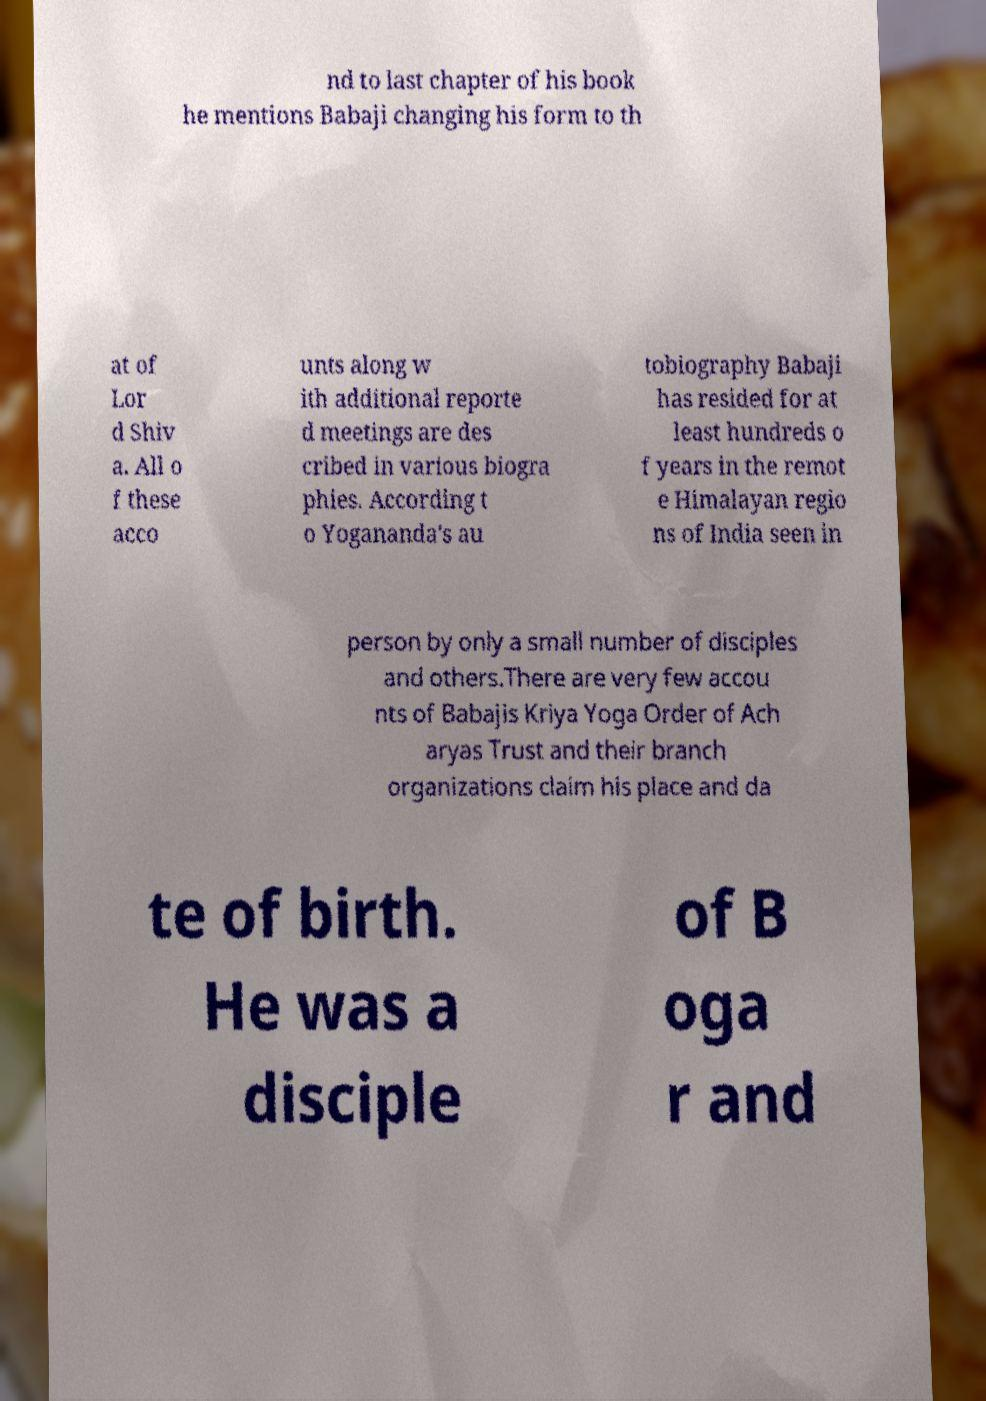I need the written content from this picture converted into text. Can you do that? nd to last chapter of his book he mentions Babaji changing his form to th at of Lor d Shiv a. All o f these acco unts along w ith additional reporte d meetings are des cribed in various biogra phies. According t o Yogananda's au tobiography Babaji has resided for at least hundreds o f years in the remot e Himalayan regio ns of India seen in person by only a small number of disciples and others.There are very few accou nts of Babajis Kriya Yoga Order of Ach aryas Trust and their branch organizations claim his place and da te of birth. He was a disciple of B oga r and 